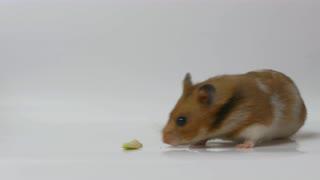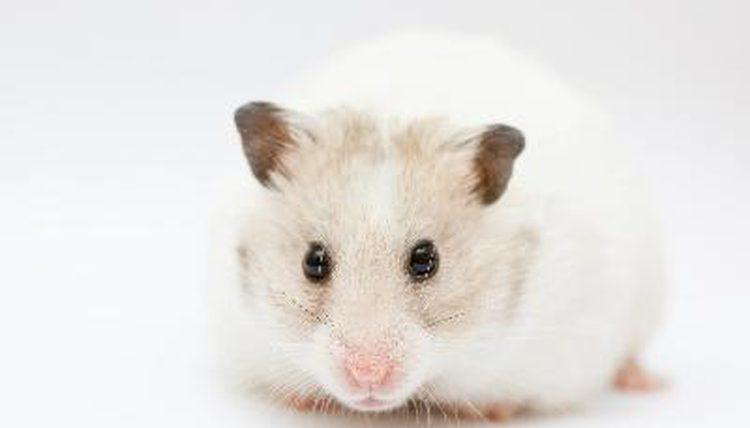The first image is the image on the left, the second image is the image on the right. Analyze the images presented: Is the assertion "An edible item is to the left of a small rodent in one image." valid? Answer yes or no. Yes. The first image is the image on the left, the second image is the image on the right. Analyze the images presented: Is the assertion "Food sits on the surface in front of a rodent in one of the images." valid? Answer yes or no. Yes. 